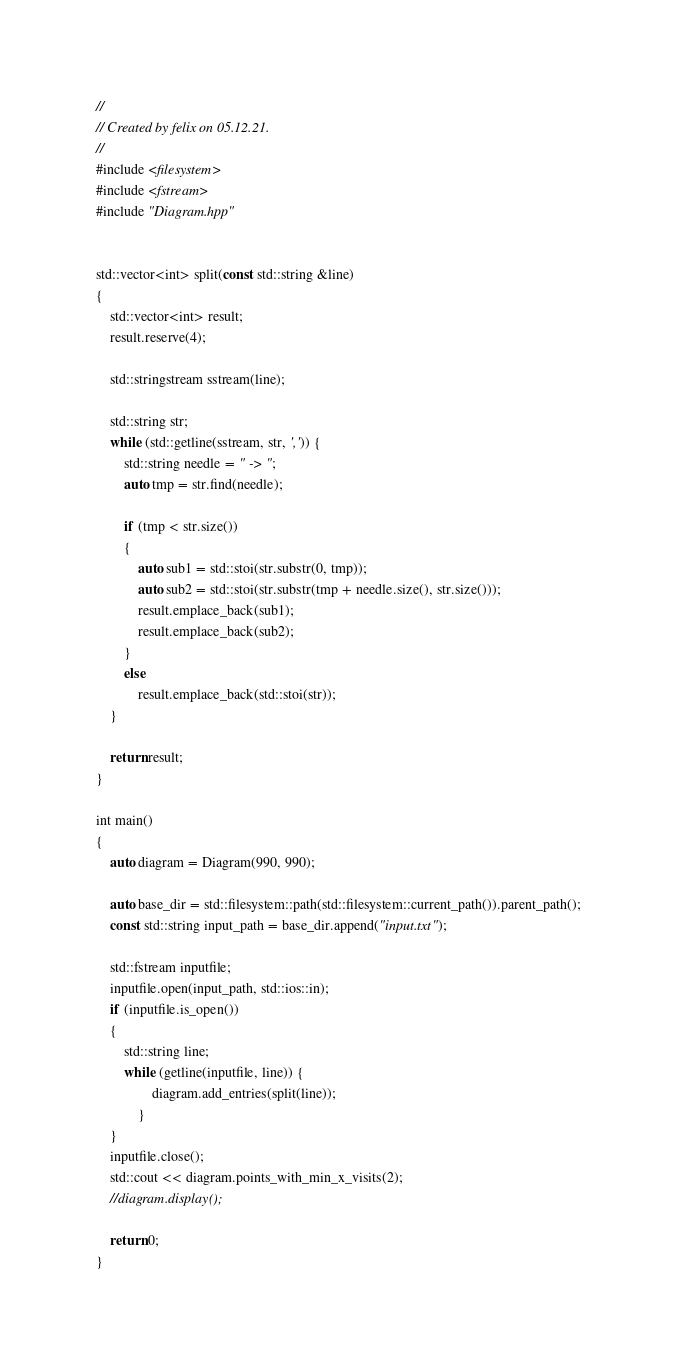<code> <loc_0><loc_0><loc_500><loc_500><_C++_>//
// Created by felix on 05.12.21.
//
#include <filesystem>
#include <fstream>
#include "Diagram.hpp"


std::vector<int> split(const std::string &line)
{
    std::vector<int> result;
    result.reserve(4);

    std::stringstream sstream(line);

    std::string str;
    while (std::getline(sstream, str, ',')) {
        std::string needle = " -> ";
        auto tmp = str.find(needle);

        if (tmp < str.size())
        {
            auto sub1 = std::stoi(str.substr(0, tmp));
            auto sub2 = std::stoi(str.substr(tmp + needle.size(), str.size()));
            result.emplace_back(sub1);
            result.emplace_back(sub2);
        }
        else
            result.emplace_back(std::stoi(str));
    }

    return result;
}

int main()
{
    auto diagram = Diagram(990, 990);

    auto base_dir = std::filesystem::path(std::filesystem::current_path()).parent_path();
    const std::string input_path = base_dir.append("input.txt");

    std::fstream inputfile;
    inputfile.open(input_path, std::ios::in);
    if (inputfile.is_open())
    {
        std::string line;
        while (getline(inputfile, line)) {
                diagram.add_entries(split(line));
            }
    }
    inputfile.close();
    std::cout << diagram.points_with_min_x_visits(2);
    //diagram.display();

    return 0;
}
</code> 